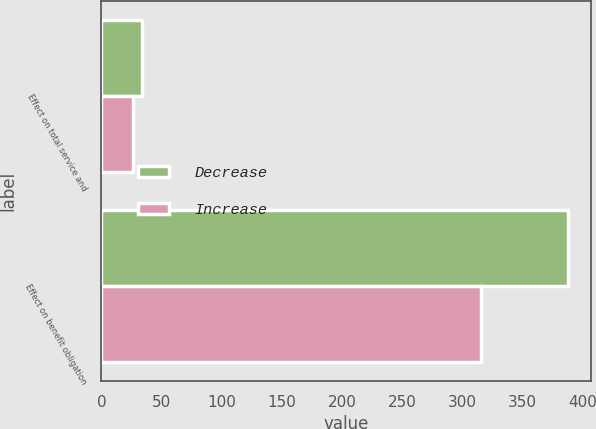Convert chart to OTSL. <chart><loc_0><loc_0><loc_500><loc_500><stacked_bar_chart><ecel><fcel>Effect on total service and<fcel>Effect on benefit obligation<nl><fcel>Decrease<fcel>33.5<fcel>387.9<nl><fcel>Increase<fcel>26.5<fcel>315.8<nl></chart> 